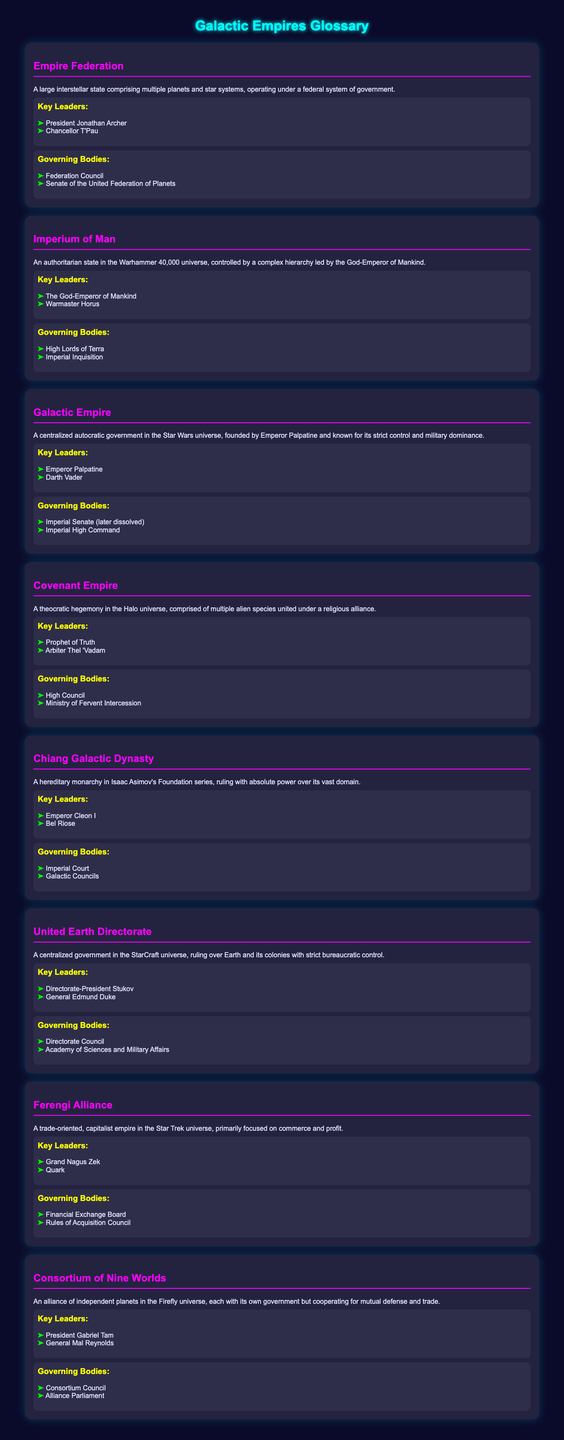What is the governing body of the Empire Federation? The governing bodies listed for the Empire Federation are the Federation Council and the Senate of the United Federation of Planets.
Answer: Federation Council Who is the key leader of the Covenant Empire? The key leaders of the Covenant Empire include the Prophet of Truth and Arbiter Thel 'Vadam.
Answer: Prophet of Truth What type of government does the Galactic Empire represent? The Galactic Empire is characterized as a centralized autocratic government.
Answer: Centralized autocratic Which empire is led by the God-Emperor of Mankind? The document mentions the Imperium of Man as having the God-Emperor of Mankind as its leader.
Answer: Imperium of Man How many key leaders are listed for the United Earth Directorate? The United Earth Directorate lists two key leaders: Directorate-President Stukov and General Edmund Duke.
Answer: Two Which governing body is associated with the Ferengi Alliance? The governing bodies associated with the Ferengi Alliance include the Financial Exchange Board and the Rules of Acquisition Council.
Answer: Financial Exchange Board What is the political structure of the Consortium of Nine Worlds? The Consortium of Nine Worlds is described as an alliance of independent planets working together for mutual defense and trade.
Answer: Alliance of independent planets Who is the President of the Consortium of Nine Worlds? The document lists President Gabriel Tam as a key leader of the Consortium of Nine Worlds.
Answer: President Gabriel Tam 